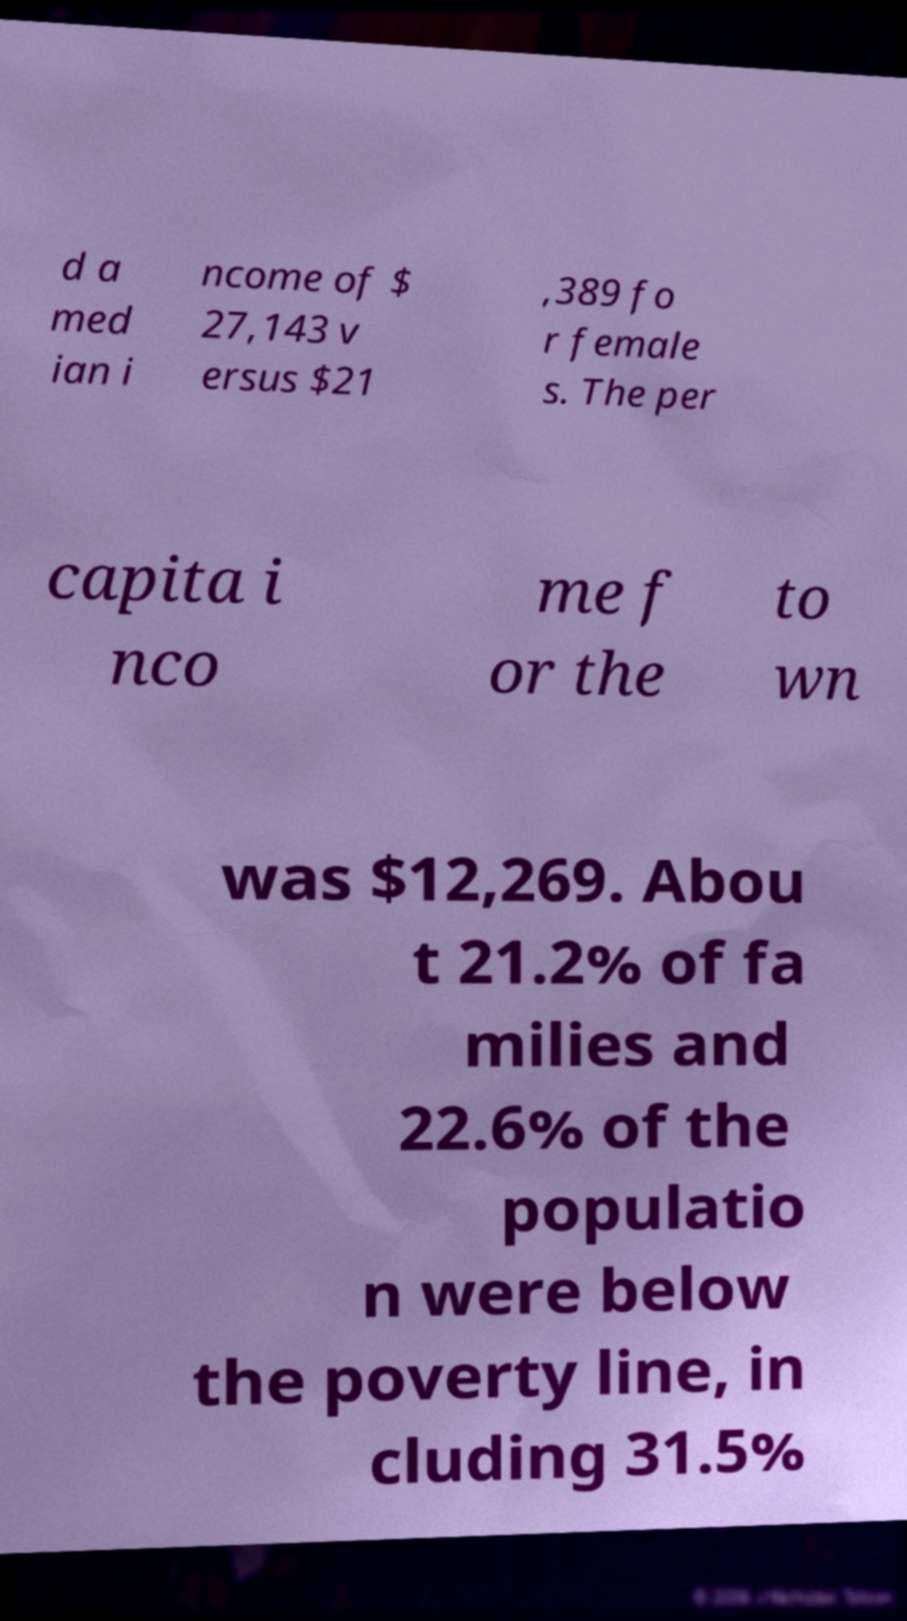There's text embedded in this image that I need extracted. Can you transcribe it verbatim? d a med ian i ncome of $ 27,143 v ersus $21 ,389 fo r female s. The per capita i nco me f or the to wn was $12,269. Abou t 21.2% of fa milies and 22.6% of the populatio n were below the poverty line, in cluding 31.5% 